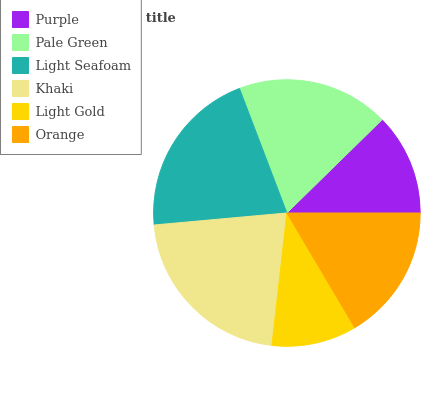Is Light Gold the minimum?
Answer yes or no. Yes. Is Khaki the maximum?
Answer yes or no. Yes. Is Pale Green the minimum?
Answer yes or no. No. Is Pale Green the maximum?
Answer yes or no. No. Is Pale Green greater than Purple?
Answer yes or no. Yes. Is Purple less than Pale Green?
Answer yes or no. Yes. Is Purple greater than Pale Green?
Answer yes or no. No. Is Pale Green less than Purple?
Answer yes or no. No. Is Pale Green the high median?
Answer yes or no. Yes. Is Orange the low median?
Answer yes or no. Yes. Is Khaki the high median?
Answer yes or no. No. Is Khaki the low median?
Answer yes or no. No. 